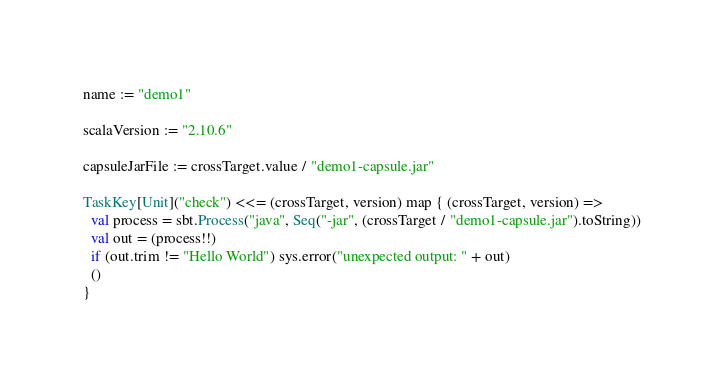<code> <loc_0><loc_0><loc_500><loc_500><_Scala_>name := "demo1"

scalaVersion := "2.10.6"

capsuleJarFile := crossTarget.value / "demo1-capsule.jar"

TaskKey[Unit]("check") <<= (crossTarget, version) map { (crossTarget, version) =>
  val process = sbt.Process("java", Seq("-jar", (crossTarget / "demo1-capsule.jar").toString))
  val out = (process!!)
  if (out.trim != "Hello World") sys.error("unexpected output: " + out)
  ()
}
</code> 